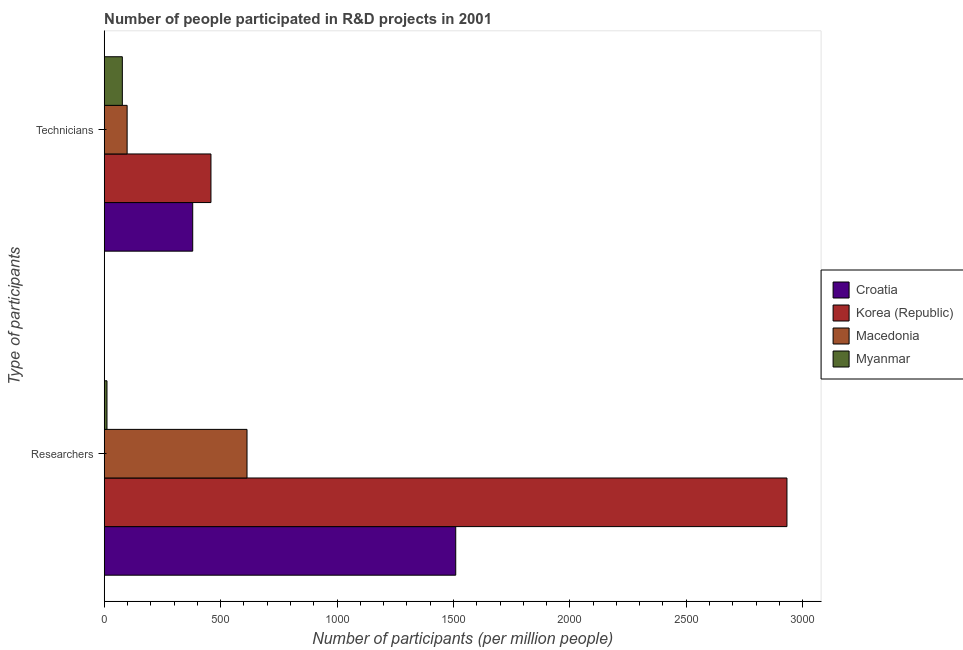How many groups of bars are there?
Make the answer very short. 2. Are the number of bars per tick equal to the number of legend labels?
Ensure brevity in your answer.  Yes. Are the number of bars on each tick of the Y-axis equal?
Your answer should be very brief. Yes. How many bars are there on the 1st tick from the top?
Ensure brevity in your answer.  4. What is the label of the 1st group of bars from the top?
Offer a very short reply. Technicians. What is the number of technicians in Macedonia?
Offer a very short reply. 98.44. Across all countries, what is the maximum number of researchers?
Offer a very short reply. 2932.46. Across all countries, what is the minimum number of researchers?
Offer a terse response. 11.91. In which country was the number of technicians minimum?
Provide a succinct answer. Myanmar. What is the total number of technicians in the graph?
Your answer should be compact. 1014.93. What is the difference between the number of technicians in Korea (Republic) and that in Myanmar?
Offer a very short reply. 380.57. What is the difference between the number of researchers in Macedonia and the number of technicians in Croatia?
Provide a short and direct response. 233.2. What is the average number of technicians per country?
Your response must be concise. 253.73. What is the difference between the number of researchers and number of technicians in Croatia?
Your response must be concise. 1129.65. What is the ratio of the number of technicians in Croatia to that in Myanmar?
Offer a terse response. 4.88. Is the number of technicians in Croatia less than that in Myanmar?
Keep it short and to the point. No. What does the 2nd bar from the top in Researchers represents?
Keep it short and to the point. Macedonia. What does the 4th bar from the bottom in Technicians represents?
Offer a very short reply. Myanmar. Are all the bars in the graph horizontal?
Provide a short and direct response. Yes. What is the difference between two consecutive major ticks on the X-axis?
Your answer should be very brief. 500. Where does the legend appear in the graph?
Your answer should be compact. Center right. How are the legend labels stacked?
Offer a very short reply. Vertical. What is the title of the graph?
Ensure brevity in your answer.  Number of people participated in R&D projects in 2001. What is the label or title of the X-axis?
Keep it short and to the point. Number of participants (per million people). What is the label or title of the Y-axis?
Your answer should be compact. Type of participants. What is the Number of participants (per million people) in Croatia in Researchers?
Offer a terse response. 1509.82. What is the Number of participants (per million people) in Korea (Republic) in Researchers?
Your answer should be very brief. 2932.46. What is the Number of participants (per million people) in Macedonia in Researchers?
Give a very brief answer. 613.38. What is the Number of participants (per million people) of Myanmar in Researchers?
Make the answer very short. 11.91. What is the Number of participants (per million people) of Croatia in Technicians?
Give a very brief answer. 380.18. What is the Number of participants (per million people) in Korea (Republic) in Technicians?
Keep it short and to the point. 458.44. What is the Number of participants (per million people) of Macedonia in Technicians?
Provide a succinct answer. 98.44. What is the Number of participants (per million people) in Myanmar in Technicians?
Ensure brevity in your answer.  77.87. Across all Type of participants, what is the maximum Number of participants (per million people) of Croatia?
Provide a succinct answer. 1509.82. Across all Type of participants, what is the maximum Number of participants (per million people) in Korea (Republic)?
Offer a very short reply. 2932.46. Across all Type of participants, what is the maximum Number of participants (per million people) in Macedonia?
Keep it short and to the point. 613.38. Across all Type of participants, what is the maximum Number of participants (per million people) in Myanmar?
Keep it short and to the point. 77.87. Across all Type of participants, what is the minimum Number of participants (per million people) in Croatia?
Your answer should be very brief. 380.18. Across all Type of participants, what is the minimum Number of participants (per million people) in Korea (Republic)?
Make the answer very short. 458.44. Across all Type of participants, what is the minimum Number of participants (per million people) of Macedonia?
Ensure brevity in your answer.  98.44. Across all Type of participants, what is the minimum Number of participants (per million people) of Myanmar?
Offer a very short reply. 11.91. What is the total Number of participants (per million people) in Croatia in the graph?
Your response must be concise. 1890. What is the total Number of participants (per million people) of Korea (Republic) in the graph?
Offer a very short reply. 3390.9. What is the total Number of participants (per million people) of Macedonia in the graph?
Give a very brief answer. 711.82. What is the total Number of participants (per million people) in Myanmar in the graph?
Provide a succinct answer. 89.78. What is the difference between the Number of participants (per million people) of Croatia in Researchers and that in Technicians?
Your response must be concise. 1129.65. What is the difference between the Number of participants (per million people) of Korea (Republic) in Researchers and that in Technicians?
Your answer should be very brief. 2474.02. What is the difference between the Number of participants (per million people) of Macedonia in Researchers and that in Technicians?
Give a very brief answer. 514.94. What is the difference between the Number of participants (per million people) in Myanmar in Researchers and that in Technicians?
Ensure brevity in your answer.  -65.96. What is the difference between the Number of participants (per million people) in Croatia in Researchers and the Number of participants (per million people) in Korea (Republic) in Technicians?
Your answer should be compact. 1051.38. What is the difference between the Number of participants (per million people) in Croatia in Researchers and the Number of participants (per million people) in Macedonia in Technicians?
Your answer should be compact. 1411.39. What is the difference between the Number of participants (per million people) of Croatia in Researchers and the Number of participants (per million people) of Myanmar in Technicians?
Provide a short and direct response. 1431.95. What is the difference between the Number of participants (per million people) in Korea (Republic) in Researchers and the Number of participants (per million people) in Macedonia in Technicians?
Keep it short and to the point. 2834.03. What is the difference between the Number of participants (per million people) of Korea (Republic) in Researchers and the Number of participants (per million people) of Myanmar in Technicians?
Make the answer very short. 2854.59. What is the difference between the Number of participants (per million people) in Macedonia in Researchers and the Number of participants (per million people) in Myanmar in Technicians?
Make the answer very short. 535.51. What is the average Number of participants (per million people) of Croatia per Type of participants?
Your response must be concise. 945. What is the average Number of participants (per million people) of Korea (Republic) per Type of participants?
Ensure brevity in your answer.  1695.45. What is the average Number of participants (per million people) in Macedonia per Type of participants?
Ensure brevity in your answer.  355.91. What is the average Number of participants (per million people) of Myanmar per Type of participants?
Ensure brevity in your answer.  44.89. What is the difference between the Number of participants (per million people) in Croatia and Number of participants (per million people) in Korea (Republic) in Researchers?
Offer a terse response. -1422.64. What is the difference between the Number of participants (per million people) in Croatia and Number of participants (per million people) in Macedonia in Researchers?
Ensure brevity in your answer.  896.44. What is the difference between the Number of participants (per million people) of Croatia and Number of participants (per million people) of Myanmar in Researchers?
Make the answer very short. 1497.92. What is the difference between the Number of participants (per million people) of Korea (Republic) and Number of participants (per million people) of Macedonia in Researchers?
Keep it short and to the point. 2319.08. What is the difference between the Number of participants (per million people) of Korea (Republic) and Number of participants (per million people) of Myanmar in Researchers?
Ensure brevity in your answer.  2920.55. What is the difference between the Number of participants (per million people) in Macedonia and Number of participants (per million people) in Myanmar in Researchers?
Your answer should be compact. 601.47. What is the difference between the Number of participants (per million people) in Croatia and Number of participants (per million people) in Korea (Republic) in Technicians?
Give a very brief answer. -78.26. What is the difference between the Number of participants (per million people) in Croatia and Number of participants (per million people) in Macedonia in Technicians?
Your answer should be compact. 281.74. What is the difference between the Number of participants (per million people) of Croatia and Number of participants (per million people) of Myanmar in Technicians?
Offer a very short reply. 302.31. What is the difference between the Number of participants (per million people) in Korea (Republic) and Number of participants (per million people) in Macedonia in Technicians?
Provide a succinct answer. 360. What is the difference between the Number of participants (per million people) of Korea (Republic) and Number of participants (per million people) of Myanmar in Technicians?
Offer a very short reply. 380.57. What is the difference between the Number of participants (per million people) in Macedonia and Number of participants (per million people) in Myanmar in Technicians?
Provide a succinct answer. 20.57. What is the ratio of the Number of participants (per million people) in Croatia in Researchers to that in Technicians?
Your answer should be very brief. 3.97. What is the ratio of the Number of participants (per million people) in Korea (Republic) in Researchers to that in Technicians?
Give a very brief answer. 6.4. What is the ratio of the Number of participants (per million people) in Macedonia in Researchers to that in Technicians?
Give a very brief answer. 6.23. What is the ratio of the Number of participants (per million people) in Myanmar in Researchers to that in Technicians?
Give a very brief answer. 0.15. What is the difference between the highest and the second highest Number of participants (per million people) in Croatia?
Make the answer very short. 1129.65. What is the difference between the highest and the second highest Number of participants (per million people) in Korea (Republic)?
Make the answer very short. 2474.02. What is the difference between the highest and the second highest Number of participants (per million people) in Macedonia?
Ensure brevity in your answer.  514.94. What is the difference between the highest and the second highest Number of participants (per million people) of Myanmar?
Your answer should be very brief. 65.96. What is the difference between the highest and the lowest Number of participants (per million people) of Croatia?
Keep it short and to the point. 1129.65. What is the difference between the highest and the lowest Number of participants (per million people) in Korea (Republic)?
Your answer should be very brief. 2474.02. What is the difference between the highest and the lowest Number of participants (per million people) of Macedonia?
Offer a terse response. 514.94. What is the difference between the highest and the lowest Number of participants (per million people) of Myanmar?
Your answer should be compact. 65.96. 